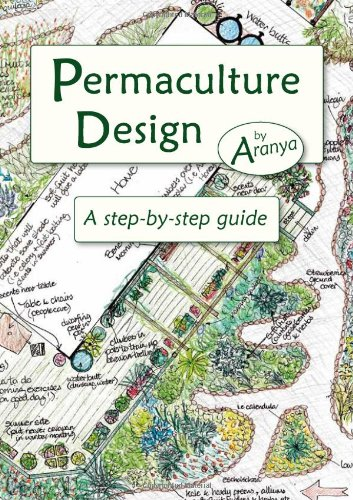Is this book related to Science & Math? Yes, this guide delves deeply into the scientific aspects of permaculture design, making it a valuable resource in the 'Science & Math' category. 